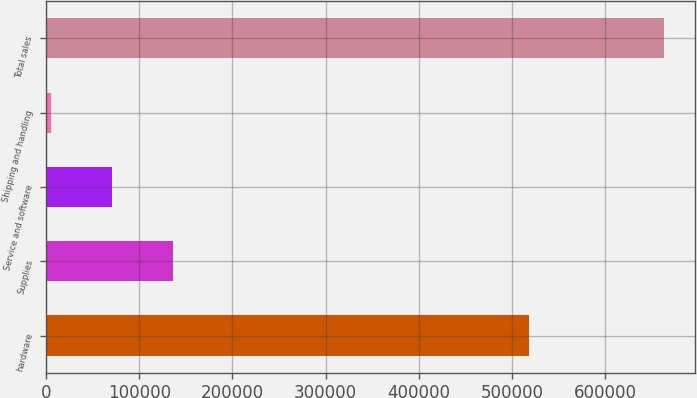Convert chart to OTSL. <chart><loc_0><loc_0><loc_500><loc_500><bar_chart><fcel>hardware<fcel>Supplies<fcel>Service and software<fcel>Shipping and handling<fcel>Total sales<nl><fcel>518556<fcel>136571<fcel>70760.4<fcel>4950<fcel>663054<nl></chart> 